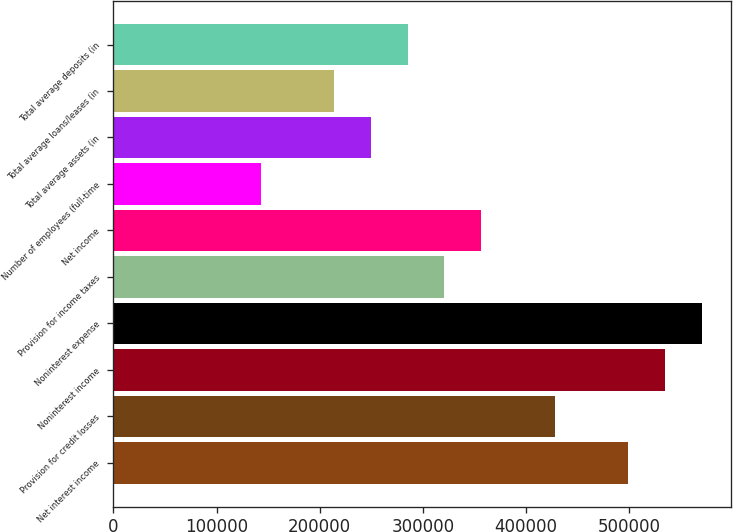<chart> <loc_0><loc_0><loc_500><loc_500><bar_chart><fcel>Net interest income<fcel>Provision for credit losses<fcel>Noninterest income<fcel>Noninterest expense<fcel>Provision for income taxes<fcel>Net income<fcel>Number of employees (full-time<fcel>Total average assets (in<fcel>Total average loans/leases (in<fcel>Total average deposits (in<nl><fcel>499117<fcel>427815<fcel>534768<fcel>570419<fcel>320862<fcel>356513<fcel>142606<fcel>249560<fcel>213909<fcel>285211<nl></chart> 